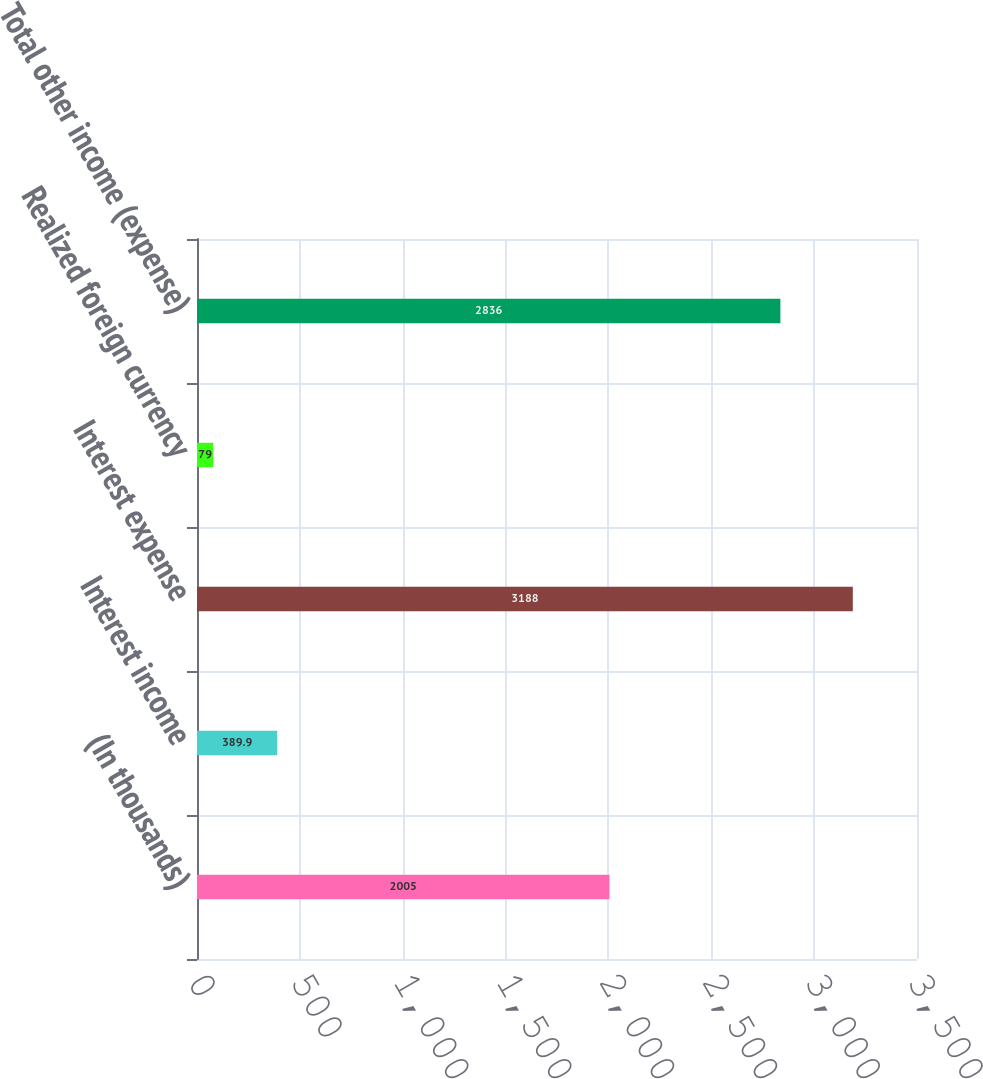<chart> <loc_0><loc_0><loc_500><loc_500><bar_chart><fcel>(In thousands)<fcel>Interest income<fcel>Interest expense<fcel>Realized foreign currency<fcel>Total other income (expense)<nl><fcel>2005<fcel>389.9<fcel>3188<fcel>79<fcel>2836<nl></chart> 